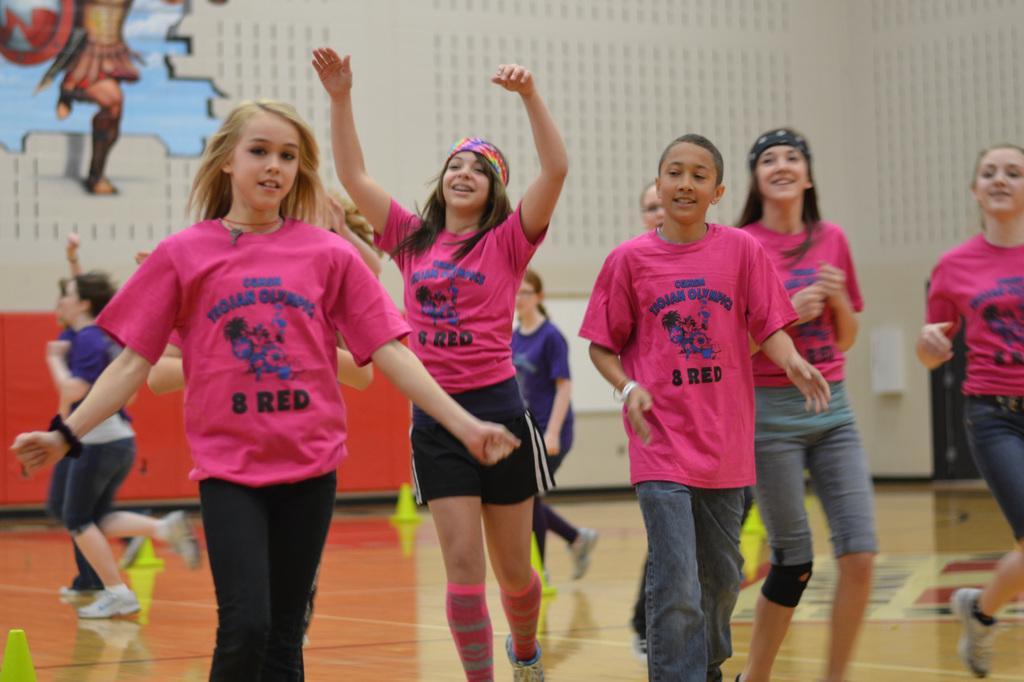Please provide a concise description of this image. In this picture we can see a few green cones on the floor. There are a few people visible from left to right. We can see a person's board in the background. 